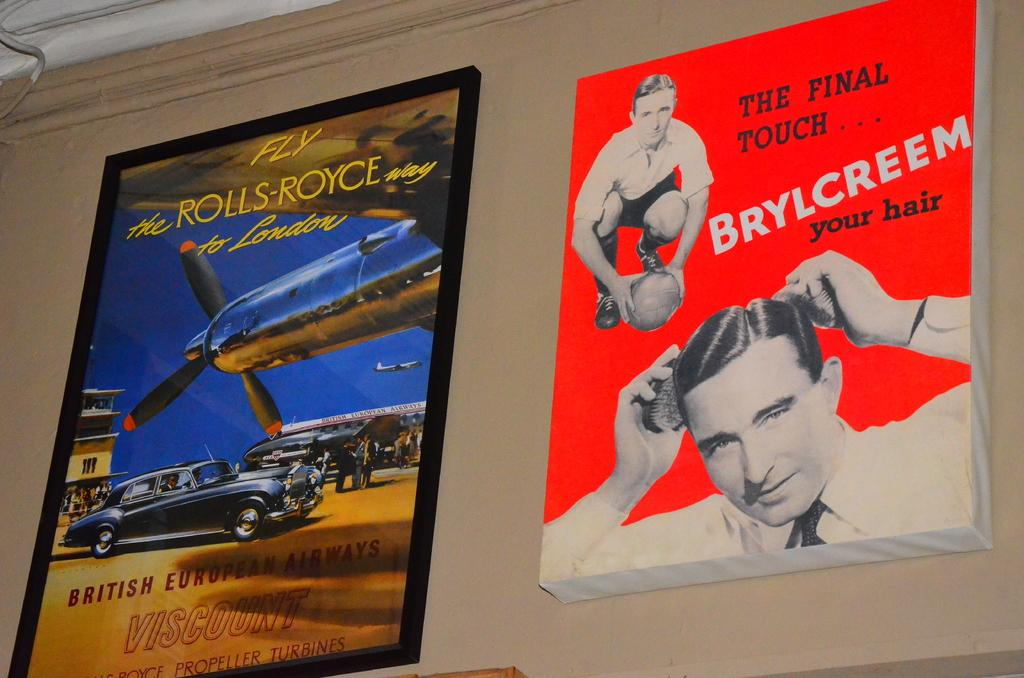<image>
Give a short and clear explanation of the subsequent image. A pair of old posters, a blue one about Rolls Royce, and a red one about a hair cream, are on the wall. 